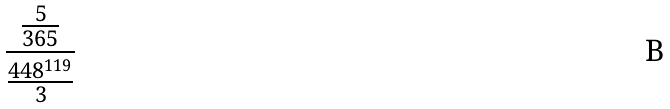<formula> <loc_0><loc_0><loc_500><loc_500>\frac { \frac { 5 } { 3 6 5 } } { \frac { 4 4 8 ^ { 1 1 9 } } { 3 } }</formula> 